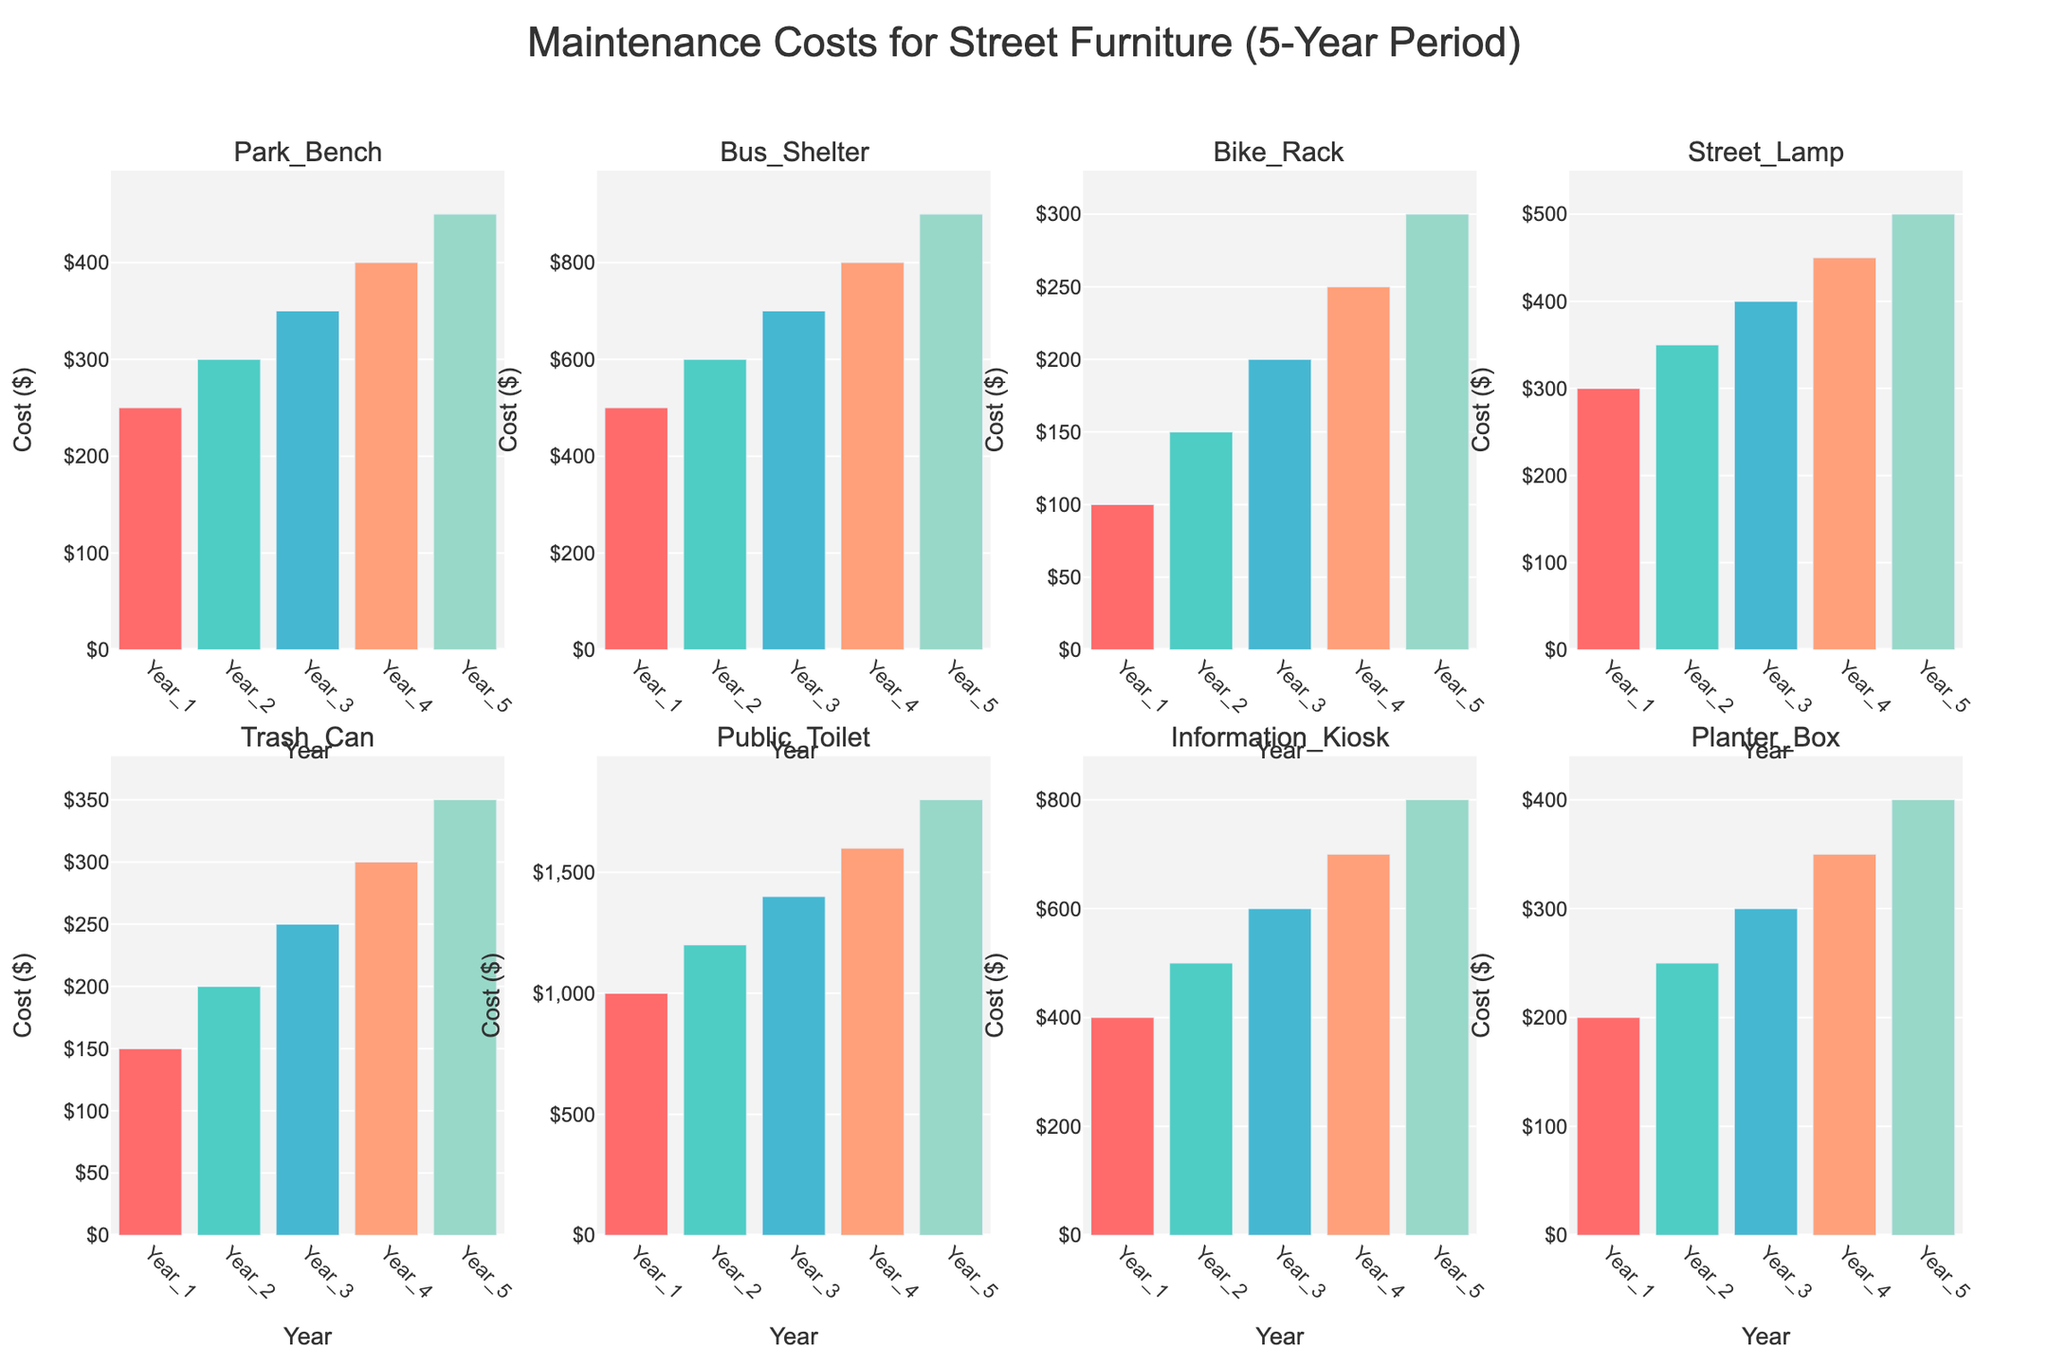How many furniture types are displayed in the subplots? Identify the number of different subplots in the figure, each representing a different furniture type.
Answer: 8 What is the title of the figure? Look at the title text that is usually displayed at the top of the figure.
Answer: Maintenance Costs for Street Furniture (5-Year Period) Which furniture type had the highest maintenance cost in Year 5? Look at the last bar in each subplot corresponding to Year 5 and compare their heights.
Answer: Public Toilet What is the maintenance cost difference for the Park Bench from Year 1 to Year 5? Subtract the maintenance cost for Park Bench in Year 1 from its maintenance cost in Year 5. The values are 450 (Year 5) - 250 (Year 1).
Answer: 200 Which furniture type had a steady year-over-year increase in maintenance cost over the 5 years? Check each subplot to identify the furniture type where each successive bar is consistently higher than the previous one.
Answer: All furniture types showed steady increases What is the average maintenance cost for the Bike Rack over the 5-year period? Add the maintenance costs for the Bike Rack over the 5 years and divide by 5. The sum is 100 + 150 + 200 + 250 + 300 = 1000, then divide by 5.
Answer: 200 What is the total maintenance cost for the Information Kiosk in the first three years combined? Add the maintenance costs for the Information Kiosk in Year 1, Year 2, and Year 3. The values are 400 + 500 + 600 = 1500.
Answer: 1500 Which two furniture types have the most similar maintenance costs across all years? Compare the bar heights for all furniture types across the years, looking for similar trends and magnitudes.
Answer: Planter Box and Park Bench Did the Trash Can's maintenance cost increase at a constant rate? Examine the height difference between successive bars in the Trash Can subplot to see if the increases are consistent.
Answer: Yes How much more did the Bus Shelter cost to maintain than the Street Lamp in Year 3? Find the difference in maintenance costs in Year 3 by subtracting the Street Lamp's cost from the Bus Shelter's cost. The values are 700 (Bus Shelter) - 400 (Street Lamp).
Answer: 300 